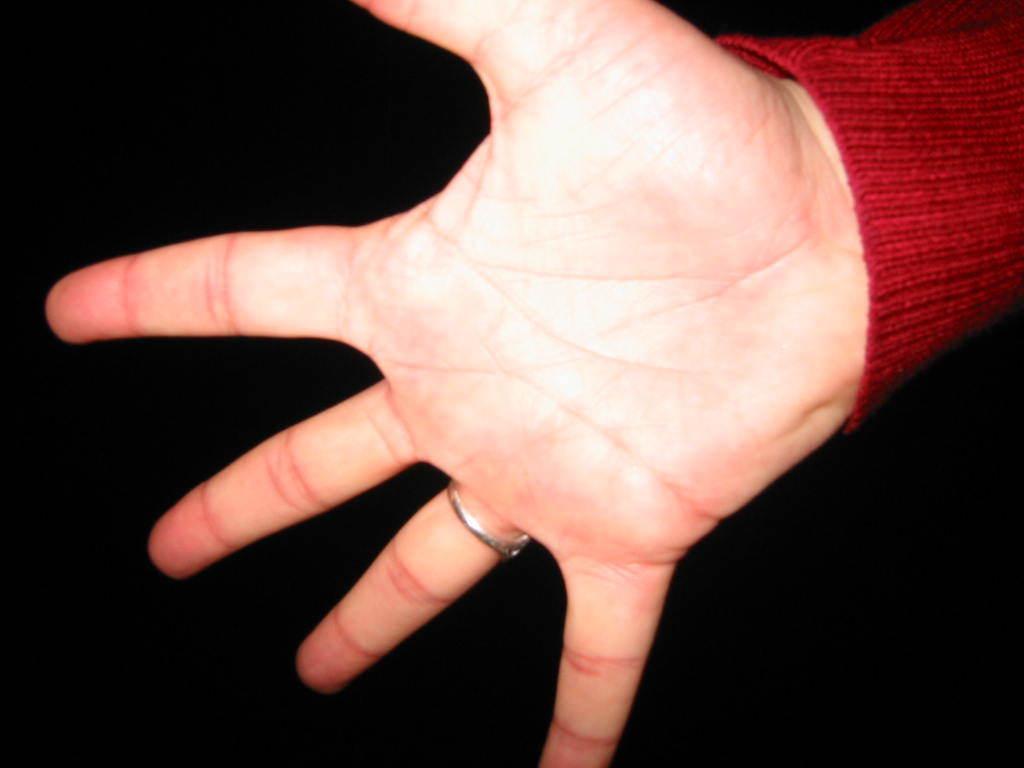Could you give a brief overview of what you see in this image? In this picture we can see a hand of a person. And there is a dark background. 